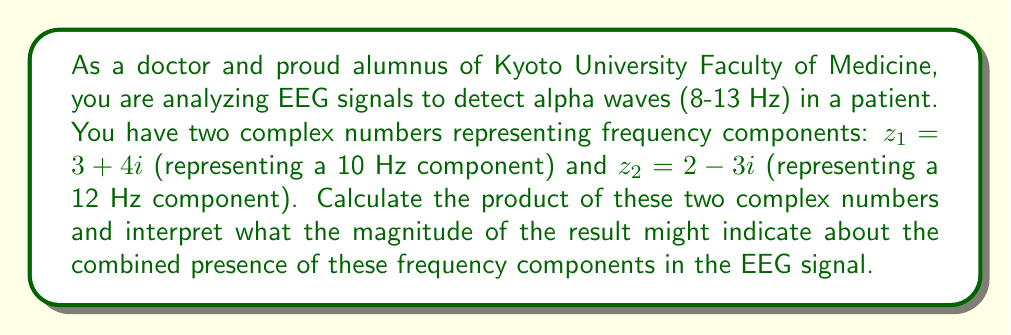Show me your answer to this math problem. To solve this problem, we'll follow these steps:

1) Multiply the two complex numbers $z_1$ and $z_2$:

   $z_1 \cdot z_2 = (3 + 4i)(2 - 3i)$

2) Use the FOIL method to multiply:
   $$ (3 + 4i)(2 - 3i) = 3(2) + 3(-3i) + 4i(2) + 4i(-3i) $$
   $$ = 6 - 9i + 8i - 12i^2 $$

3) Simplify, remembering that $i^2 = -1$:
   $$ = 6 - 9i + 8i + 12 $$
   $$ = 18 - i $$

4) The result is in the form $a + bi$, where $a = 18$ and $b = -1$.

5) To find the magnitude, use the formula $|z| = \sqrt{a^2 + b^2}$:
   $$ |z| = \sqrt{18^2 + (-1)^2} = \sqrt{324 + 1} = \sqrt{325} \approx 18.03 $$

Interpretation: The magnitude of the product (18.03) is significantly larger than either of the original magnitudes ($\sqrt{3^2 + 4^2} = 5$ for $z_1$ and $\sqrt{2^2 + (-3)^2} \approx 3.61$ for $z_2$). This suggests a strong combined presence of both frequency components (10 Hz and 12 Hz) in the alpha wave range of the EEG signal. The large magnitude could indicate that these frequencies are prominent and potentially synchronous in the patient's brain activity.
Answer: The product of the two complex numbers is $18 - i$, with a magnitude of approximately 18.03. This large magnitude suggests a strong combined presence of both 10 Hz and 12 Hz components in the alpha wave range of the EEG signal. 